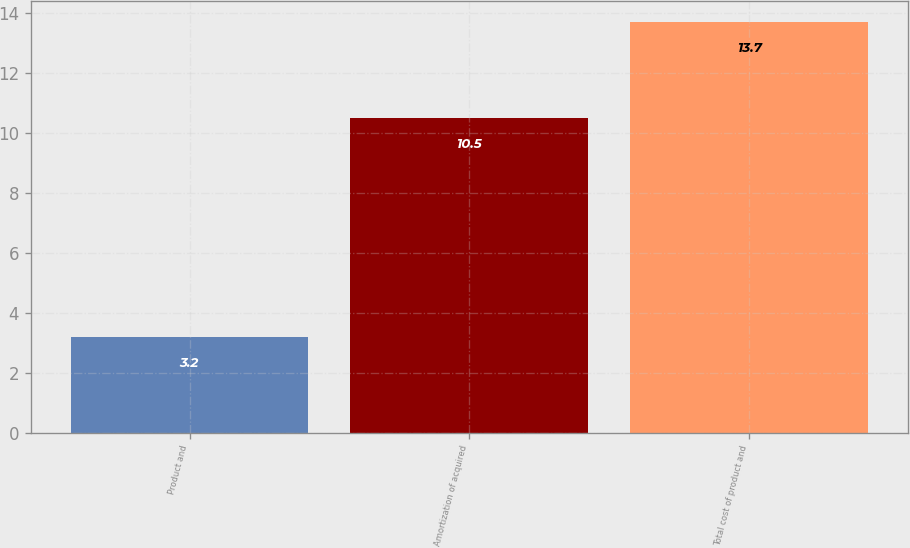Convert chart to OTSL. <chart><loc_0><loc_0><loc_500><loc_500><bar_chart><fcel>Product and<fcel>Amortization of acquired<fcel>Total cost of product and<nl><fcel>3.2<fcel>10.5<fcel>13.7<nl></chart> 